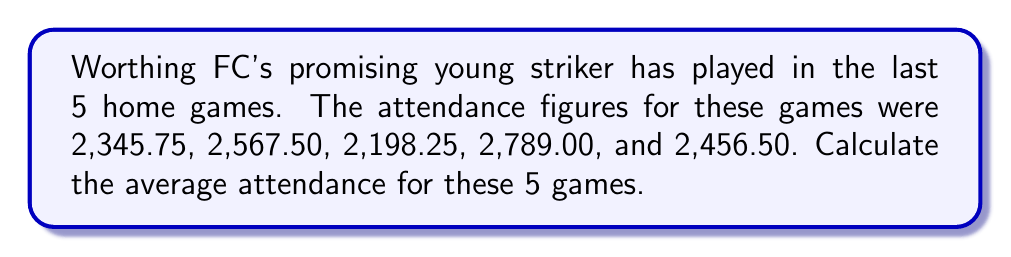What is the answer to this math problem? To find the average attendance, we need to follow these steps:

1. Sum up all the attendance figures:
   $$2,345.75 + 2,567.50 + 2,198.25 + 2,789.00 + 2,456.50$$

2. Divide the sum by the number of games (5):

   Let's break this down:
   
   $$\frac{2,345.75 + 2,567.50 + 2,198.25 + 2,789.00 + 2,456.50}{5}$$

   $$= \frac{12,357.00}{5}$$

3. Perform the division:

   $$12,357.00 \div 5 = 2,471.40$$

Therefore, the average attendance for these 5 games is 2,471.40 people.
Answer: $2,471.40$ 